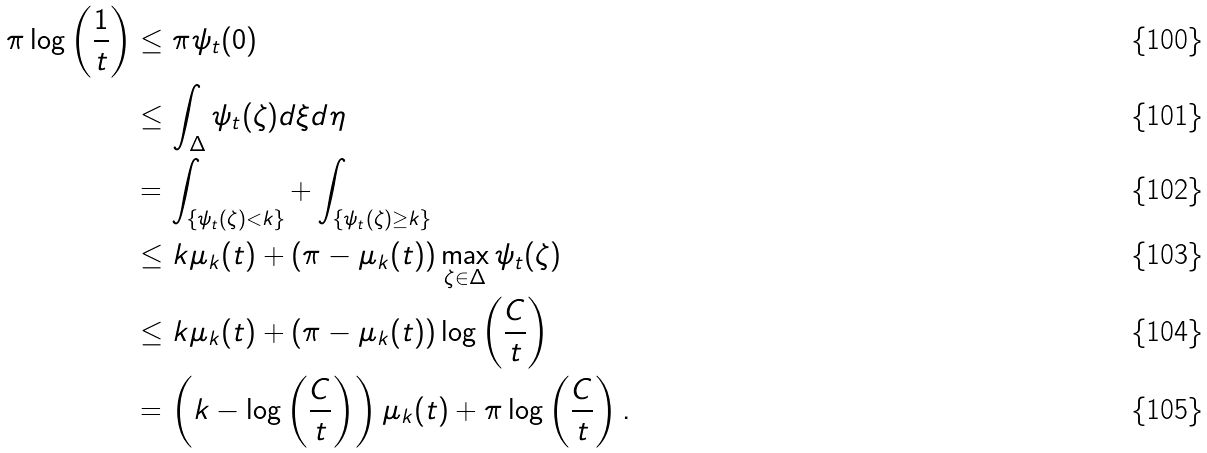Convert formula to latex. <formula><loc_0><loc_0><loc_500><loc_500>\pi \log \left ( \frac { 1 } { t } \right ) & \leq \pi \psi _ { t } ( 0 ) \\ & \leq \int _ { \Delta } \psi _ { t } ( \zeta ) d \xi d \eta \\ & = \int _ { \{ \psi _ { t } ( \zeta ) < k \} } + \int _ { \{ \psi _ { t } ( \zeta ) \geq k \} } \\ & \leq k \mu _ { k } ( t ) + ( \pi - \mu _ { k } ( t ) ) \max _ { \zeta \in \Delta } \psi _ { t } ( \zeta ) \\ & \leq k \mu _ { k } ( t ) + ( \pi - \mu _ { k } ( t ) ) \log \left ( \frac { C } { t } \right ) \\ & = \left ( k - \log \left ( \frac { C } { t } \right ) \right ) \mu _ { k } ( t ) + \pi \log \left ( \frac { C } { t } \right ) .</formula> 